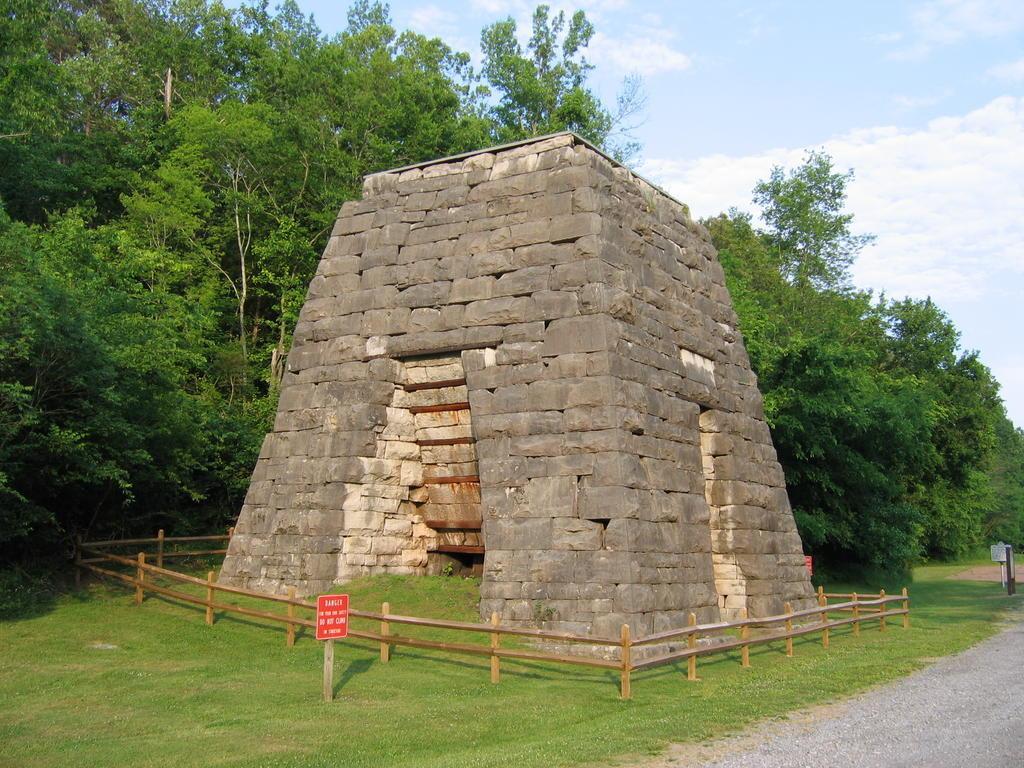Describe this image in one or two sentences. In this picture we can see some grass on the ground. We can see the road in the bottom right. There are boards visible on the poles. We can see some wooden fencing around a block with stone walls. There are a few trees visible in the background. Sky is blue in color and cloudy. 